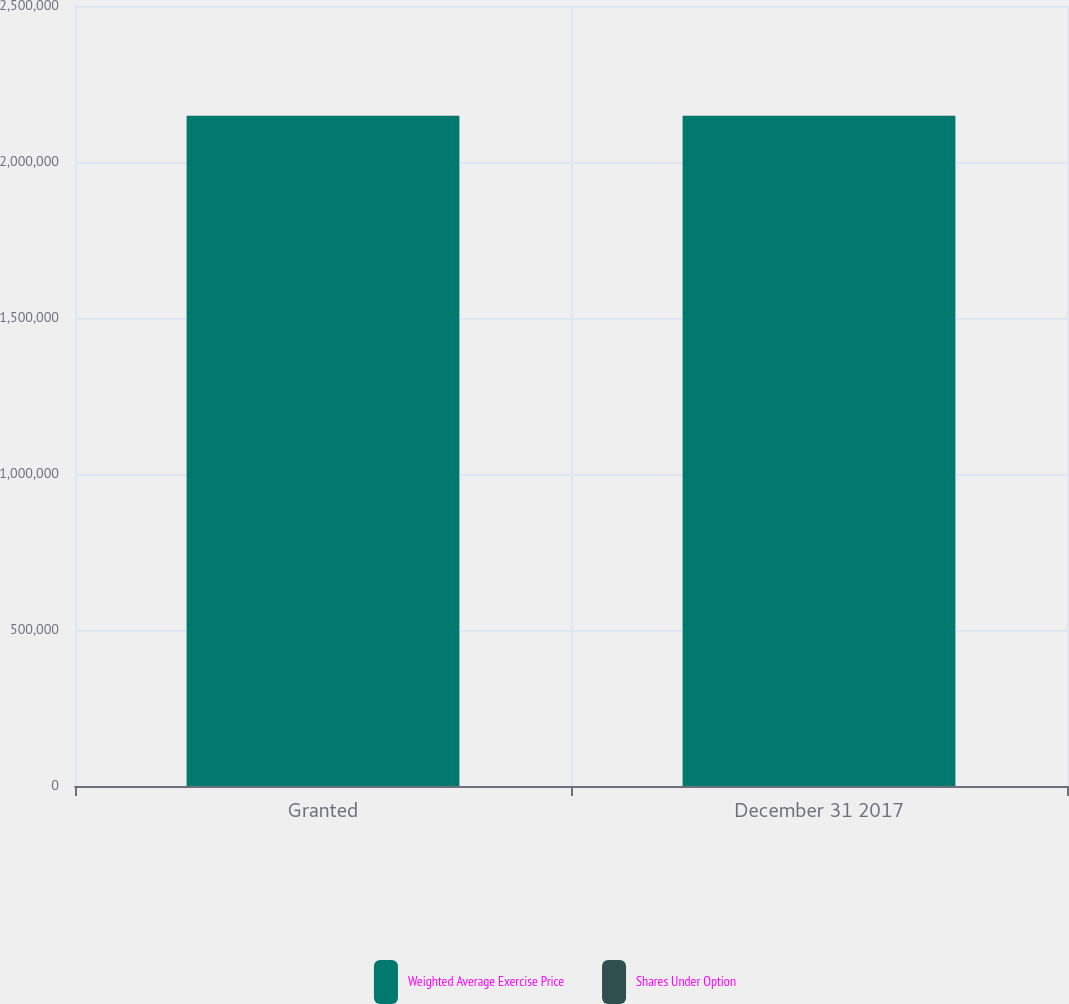Convert chart to OTSL. <chart><loc_0><loc_0><loc_500><loc_500><stacked_bar_chart><ecel><fcel>Granted<fcel>December 31 2017<nl><fcel>Weighted Average Exercise Price<fcel>2.14756e+06<fcel>2.14756e+06<nl><fcel>Shares Under Option<fcel>513.5<fcel>513.5<nl></chart> 